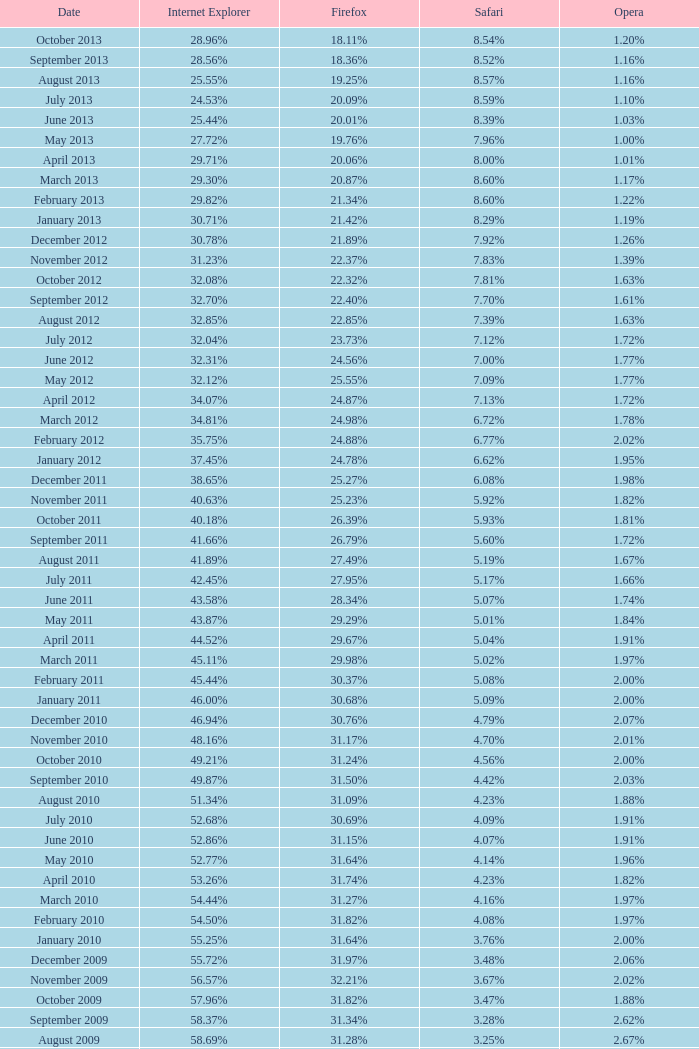What fraction of browsers employed opera in october 2010? 2.00%. 